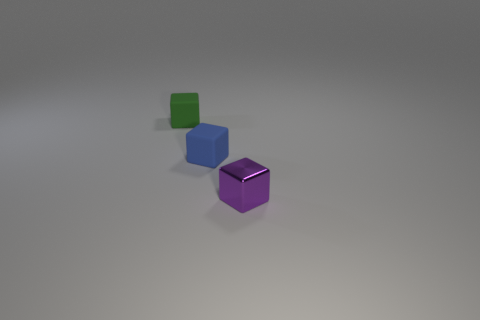How many objects are either small objects that are in front of the small green thing or small green blocks?
Your answer should be compact. 3. What is the size of the blue thing that is made of the same material as the green thing?
Provide a succinct answer. Small. Are there more small purple objects left of the small blue matte cube than small purple things?
Your response must be concise. No. Does the purple thing have the same shape as the object to the left of the blue cube?
Give a very brief answer. Yes. What number of large things are blocks or matte blocks?
Provide a succinct answer. 0. The tiny rubber cube on the right side of the small rubber object that is left of the blue object is what color?
Ensure brevity in your answer.  Blue. Does the tiny green cube have the same material as the small block on the right side of the blue rubber block?
Offer a terse response. No. What is the blue thing that is to the right of the small green cube made of?
Ensure brevity in your answer.  Rubber. Are there an equal number of rubber objects that are on the left side of the metal object and green matte objects?
Offer a very short reply. No. Are there any other things that are the same size as the purple metal object?
Your answer should be compact. Yes. 